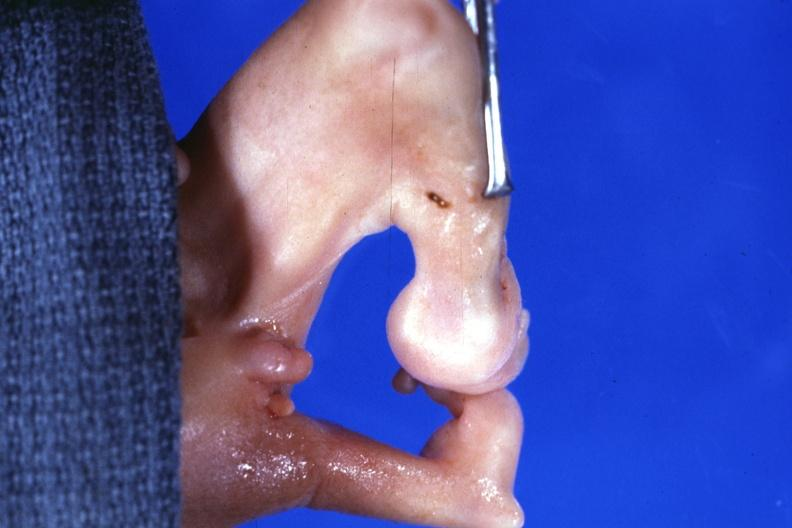s dysplastic present?
Answer the question using a single word or phrase. Yes 